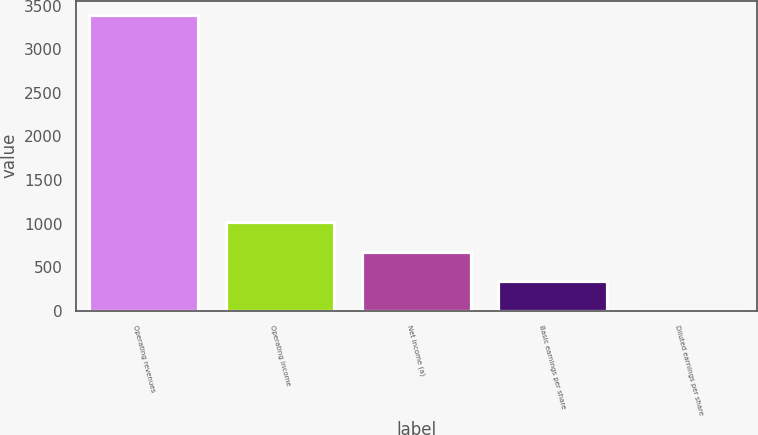<chart> <loc_0><loc_0><loc_500><loc_500><bar_chart><fcel>Operating revenues<fcel>Operating income<fcel>Net income (a)<fcel>Basic earnings per share<fcel>Diluted earnings per share<nl><fcel>3390<fcel>1018.03<fcel>679.18<fcel>340.33<fcel>1.48<nl></chart> 